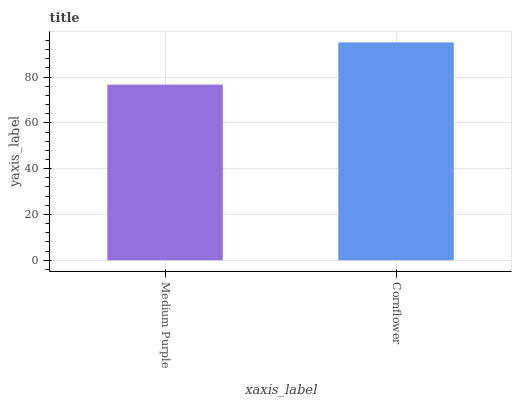Is Medium Purple the minimum?
Answer yes or no. Yes. Is Cornflower the maximum?
Answer yes or no. Yes. Is Cornflower the minimum?
Answer yes or no. No. Is Cornflower greater than Medium Purple?
Answer yes or no. Yes. Is Medium Purple less than Cornflower?
Answer yes or no. Yes. Is Medium Purple greater than Cornflower?
Answer yes or no. No. Is Cornflower less than Medium Purple?
Answer yes or no. No. Is Cornflower the high median?
Answer yes or no. Yes. Is Medium Purple the low median?
Answer yes or no. Yes. Is Medium Purple the high median?
Answer yes or no. No. Is Cornflower the low median?
Answer yes or no. No. 